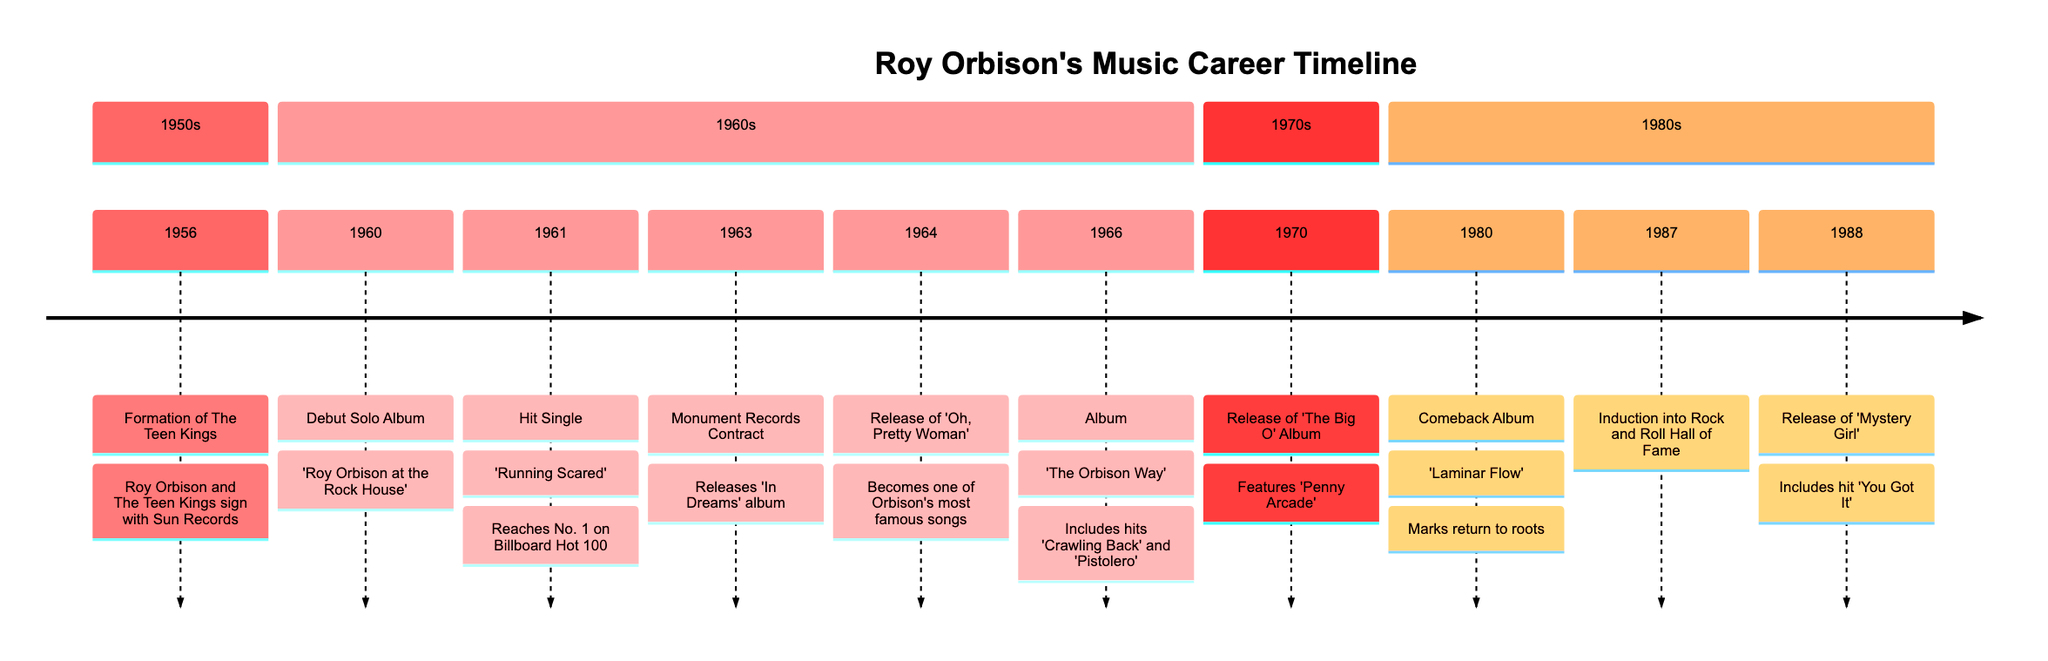What year did Roy Orbison form The Teen Kings? The timeline states that the formation of The Teen Kings occurred in 1956. Therefore, by directly referencing the event listed in the timeline, we can pinpoint the exact year.
Answer: 1956 What was Roy Orbison's first major hit single? The timeline specifies that 'Running Scared' was Orbison's first major hit, which reached No. 1 on the Billboard Hot 100 chart in 1961. This information is gathered directly from the entry concerning the hit single.
Answer: Running Scared Which album was released in 1964 featuring one of Orbison's most famous songs? According to the timeline, 'Oh, Pretty Woman' was released in 1964, making this the album that features one of Orbison's most well-known songs. This is confirmed by the description provided for that specific year.
Answer: Oh, Pretty Woman How many albums did Roy Orbison release between 1956 and 1988? By counting the distinct entries in the timeline related to the albums released, we find that he released a total of 9 albums over the years noted in the timeline. Starting from 1956 with The Teen Kings to the last one noted in 1988, 'Mystery Girl'.
Answer: 9 What is the significance of the year 1987 in Roy Orbison's career? The timeline highlights the year 1987 as the year Roy Orbison was inducted into the Rock and Roll Hall of Fame. This indicates a significant recognition of his contributions to music, as noted in the description for that year.
Answer: Induction into Rock and Roll Hall of Fame Which album includes the hit 'You Got It'? The entry for the year 1988 indicates that the album 'Mystery Girl' includes the hit 'You Got It'. This can be directly gleaned from the event's details listed in the timeline.
Answer: Mystery Girl What year marks Roy Orbison's comeback album release? According to the timeline, the year 1980 is cited as the year Roy Orbison released his comeback album 'Laminar Flow'. This information is taken from the description under that specific year.
Answer: 1980 In what year did Roy Orbison sign a contract with Monument Records? The timeline states that Roy Orbison signed a contract with Monument Records in 1963, coinciding with the release of the album 'In Dreams'. This information can be directly referenced from the details of that year.
Answer: 1963 Which song reached No. 1 on the Billboard Hot 100 chart in 1961? The timeline explicitly mentions 'Running Scared' as the song that reached No. 1 on the Billboard Hot 100 chart in 1961. Thus, this is the short answer derived from the entry for that year.
Answer: Running Scared 